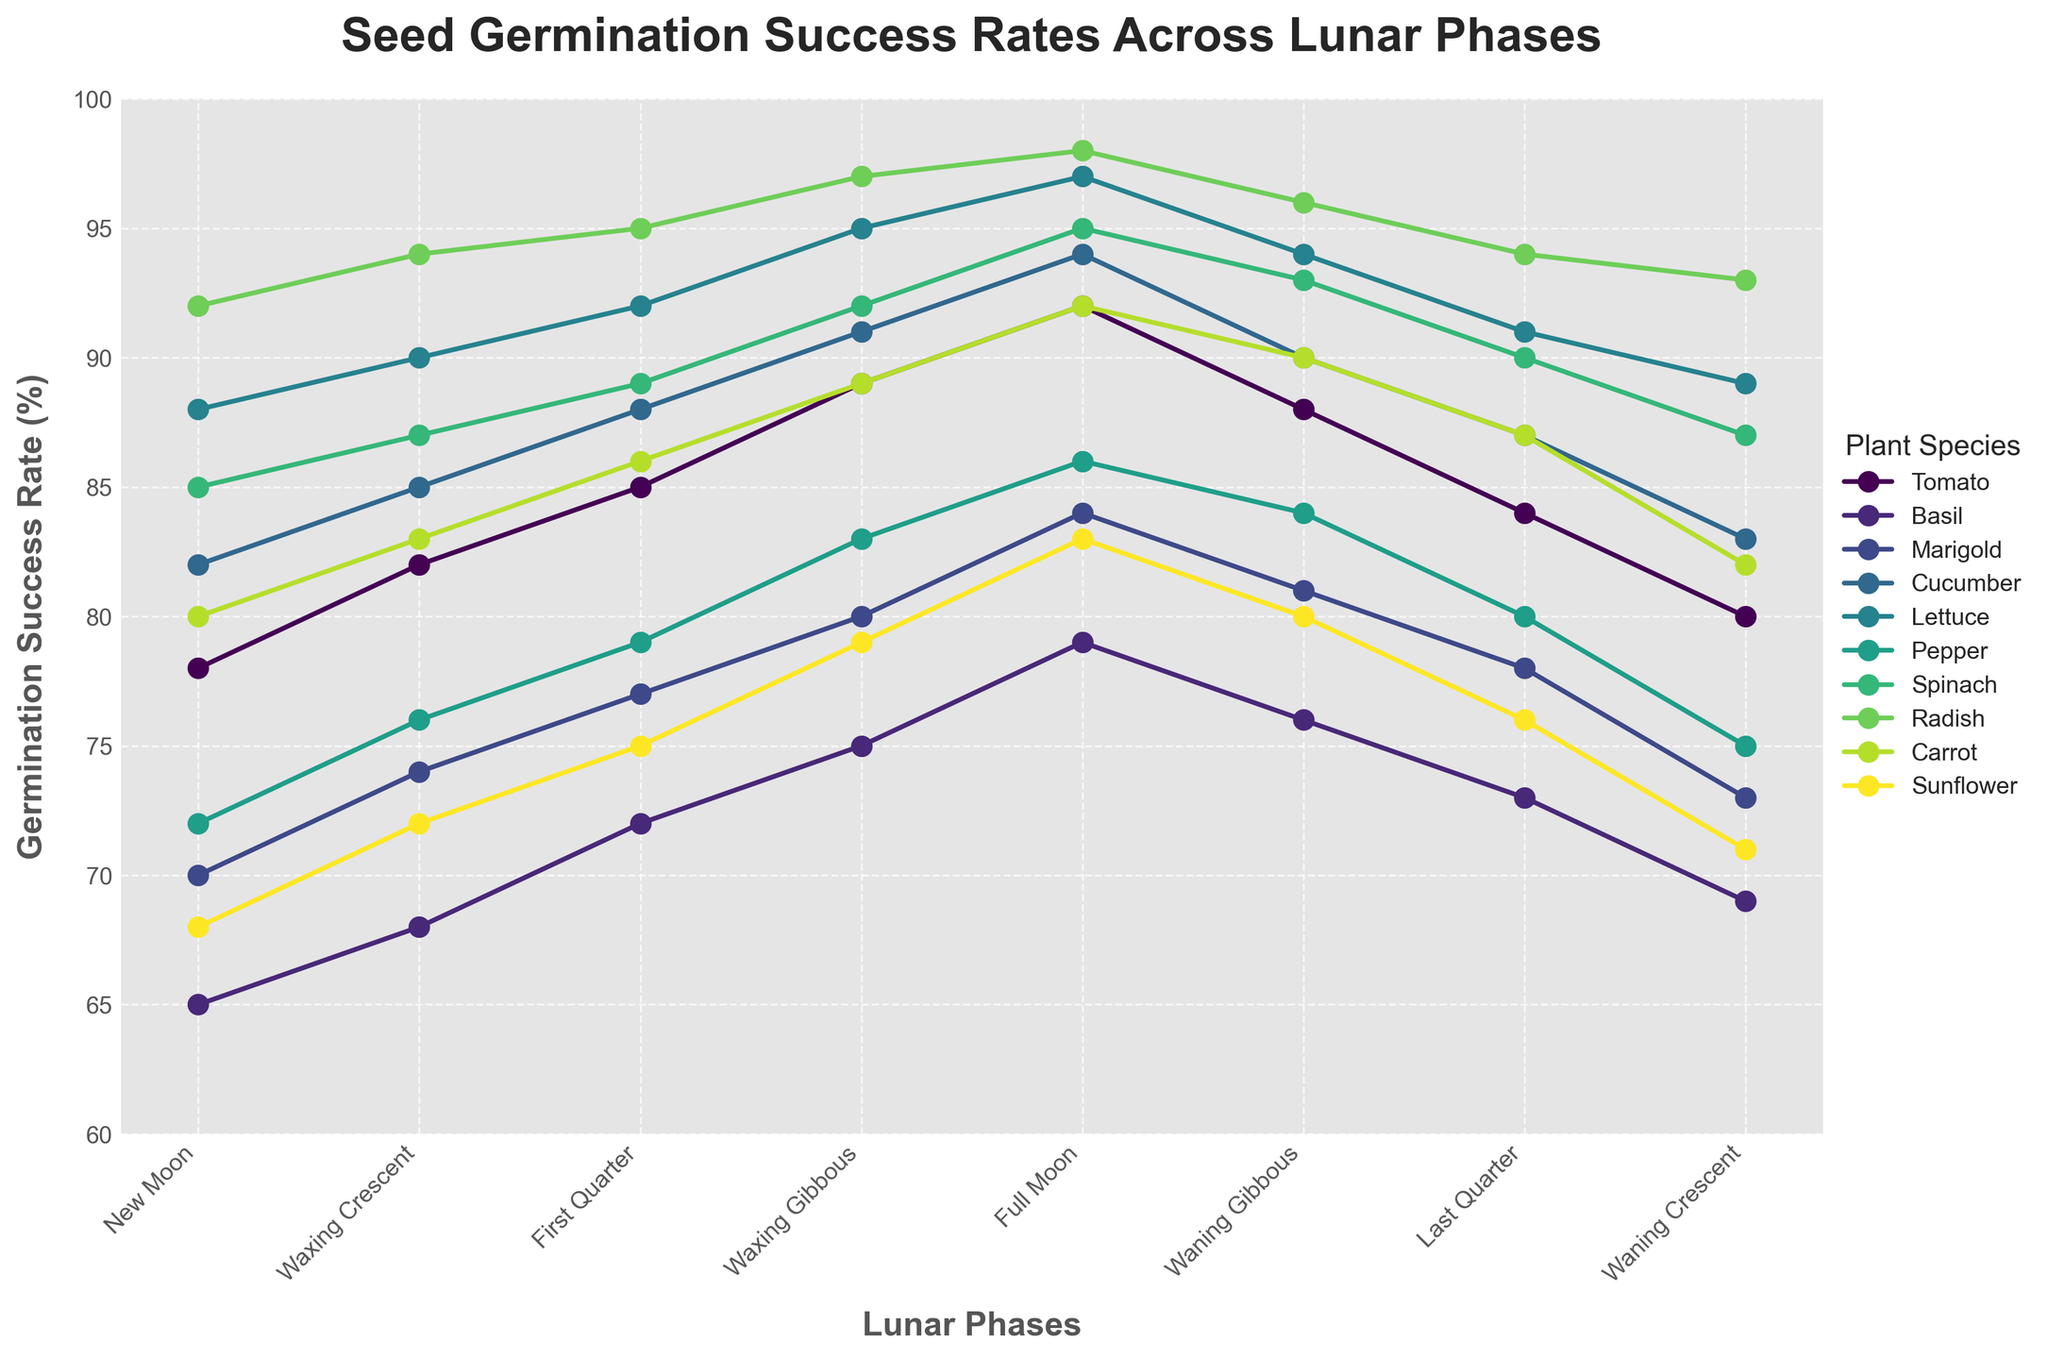What's the plant species with the highest germination rate during the Full Moon phase? Look at the Full Moon column and find the highest value. The highest germination rate during the Full Moon phase is for Radish, at 98%.
Answer: Radish Which plant has the lowest germination success rate during the New Moon phase? Reference the New Moon column and identify the lowest value, which is for Sunflower at 68%.
Answer: Sunflower What is the average germination success rate of Tomato across all lunar phases? To find the average, sum up all the germination rates for Tomato (78 + 82 + 85 + 89 + 92 + 88 + 84 + 80) = 678, then divide by the number of phases, which is 8: 678 / 8 = 84.75
Answer: 84.75 How does the germination rate of Basil during the Waxing Gibbous phase compare to Carrot? For the Waxing Gibbous phase, Basil has a success rate of 75% while Carrot has 89%. Comparing these two values, Carrot has a higher rate.
Answer: Carrot What is the difference in germination success rates between Spinach and Pepper during the Waning Gibbous phase? For the Waning Gibbous phase, Spinach has a rate of 93%, and Pepper has 84%. The difference is 93% - 84% = 9%.
Answer: 9 Which phase shows the highest germination success rate overall, and for which plant? Scan across all phases and plants, the highest rate is during the Full Moon phase for Radish at 98%.
Answer: Full Moon for Radish Calculate the median germination success rate for Sunflower across all phases. List Sunflower's rates in ascending order: (68, 71, 72, 75, 76, 79, 80, 83). The median is the average of the 4th and 5th values: (75 + 76) / 2 = 75.5
Answer: 75.5 Compare the germination success rates of Cucumber and Lettuce during the First Quarter phase and determine how much higher one is compared to the other. Cucumber's rate is 88% and Lettuce's is 92%. The difference is 92% - 88% = 4%. Lettuce is 4% higher.
Answer: Lettuce, 4% Between Marigold and Pepper, which plant sees a greater increase in germination rates from the New Moon to the Full Moon phase? Marigold increases from 70% to 84%, a difference of 14%. Pepper increases from 72% to 86%, a difference of 14%. Both increase by the same amount.
Answer: Both, 14% During which lunar phase does Spinach have its lowest germination rate, and what is the rate? Look at Spinach's data and identify the lowest value, which is during the New Moon phase at 85%.
Answer: New Moon, 85 